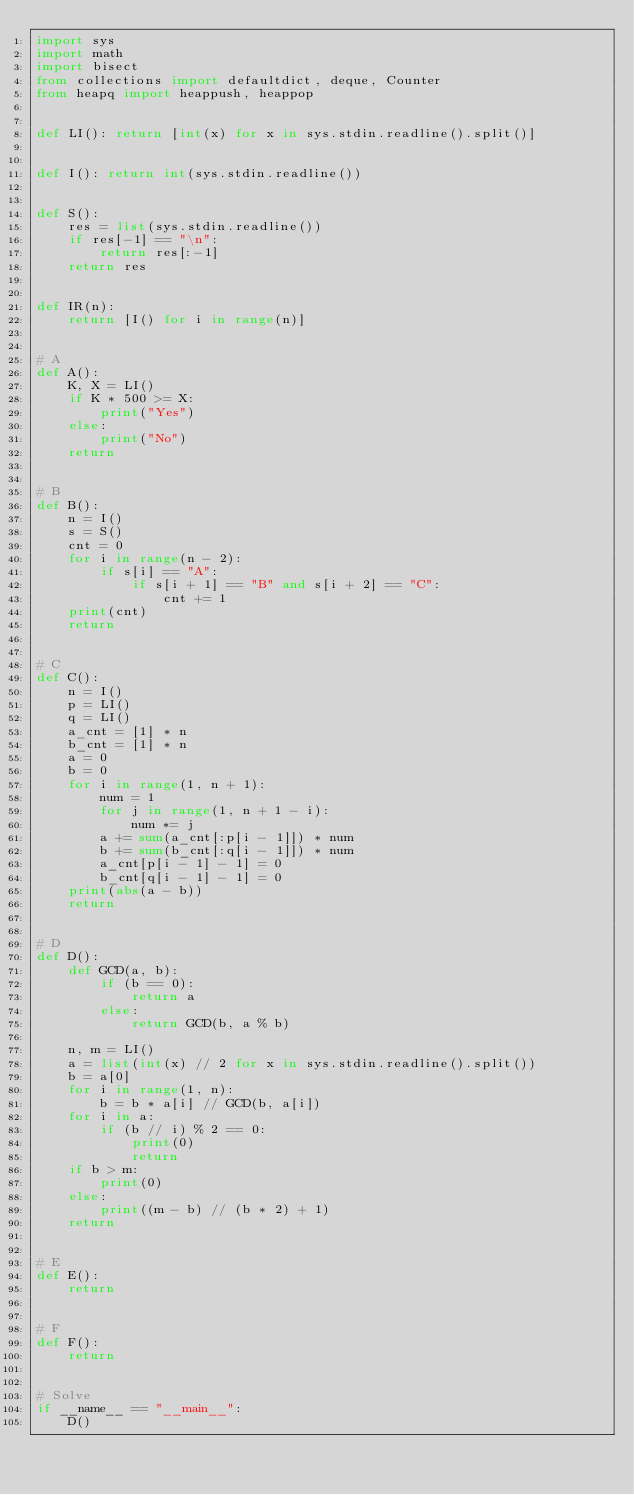<code> <loc_0><loc_0><loc_500><loc_500><_Python_>import sys
import math
import bisect
from collections import defaultdict, deque, Counter
from heapq import heappush, heappop


def LI(): return [int(x) for x in sys.stdin.readline().split()]


def I(): return int(sys.stdin.readline())


def S():
    res = list(sys.stdin.readline())
    if res[-1] == "\n":
        return res[:-1]
    return res


def IR(n):
    return [I() for i in range(n)]


# A
def A():
    K, X = LI()
    if K * 500 >= X:
        print("Yes")
    else:
        print("No")
    return


# B
def B():
    n = I()
    s = S()
    cnt = 0
    for i in range(n - 2):
        if s[i] == "A":
            if s[i + 1] == "B" and s[i + 2] == "C":
                cnt += 1
    print(cnt)
    return


# C
def C():
    n = I()
    p = LI()
    q = LI()
    a_cnt = [1] * n
    b_cnt = [1] * n
    a = 0
    b = 0
    for i in range(1, n + 1):
        num = 1
        for j in range(1, n + 1 - i):
            num *= j
        a += sum(a_cnt[:p[i - 1]]) * num
        b += sum(b_cnt[:q[i - 1]]) * num
        a_cnt[p[i - 1] - 1] = 0
        b_cnt[q[i - 1] - 1] = 0
    print(abs(a - b))
    return


# D
def D():
    def GCD(a, b):
        if (b == 0):
            return a
        else:
            return GCD(b, a % b)

    n, m = LI()
    a = list(int(x) // 2 for x in sys.stdin.readline().split())
    b = a[0]
    for i in range(1, n):
        b = b * a[i] // GCD(b, a[i])
    for i in a:
        if (b // i) % 2 == 0:
            print(0)
            return
    if b > m:
        print(0)
    else:
        print((m - b) // (b * 2) + 1)
    return


# E
def E():
    return


# F
def F():
    return


# Solve
if __name__ == "__main__":
    D()
</code> 